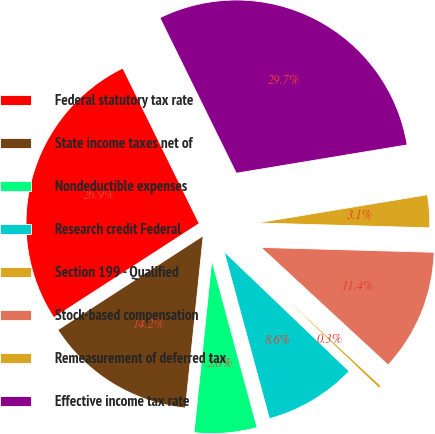Convert chart. <chart><loc_0><loc_0><loc_500><loc_500><pie_chart><fcel>Federal statutory tax rate<fcel>State income taxes net of<fcel>Nondeductible expenses<fcel>Research credit Federal<fcel>Section 199 - Qualified<fcel>Stock-based compensation<fcel>Remeasurement of deferred tax<fcel>Effective income tax rate<nl><fcel>26.87%<fcel>14.22%<fcel>5.85%<fcel>8.64%<fcel>0.27%<fcel>11.43%<fcel>3.06%<fcel>29.66%<nl></chart> 